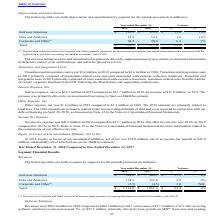According to Black Knight Financial Services's financial document, Why did Depreciation and Amortization increase? implementation of new clients, accelerated amortization of deferred contract costs and hardware and software placed in service.. The document states: "preciation and Amortization is primarily driven by implementation of new clients, accelerated amortization of deferred contract costs and hardware and..." Also, Which years does the table provide information for depreciation and amortization by segment? The document shows two values: 2019 and 2018. From the document: "2019 2018 $ % 2019 2018 $ %..." Also, What was the dollar variance for Data and Analytics? According to the financial document, 1.8 (in millions). The relevant text states: "Data and Analytics 15.9 14.1 1.8 13%..." Also, can you calculate: What was the difference in the percent variance between Software Solutions and Data and Analytics? Based on the calculation: 13-10, the result is 3 (percentage). This is based on the information: "Software Solutions $ 123.9 $ 112.9 $ 11.0 10% Data and Analytics 15.9 14.1 1.8 13%..." The key data points involved are: 10, 13. Also, can you calculate: What was the average depreciation and amortization for Software Solutions between 2018 and 2019? To answer this question, I need to perform calculations using the financial data. The calculation is: (123.9+112.9)/2, which equals 118.4 (in millions). This is based on the information: "Software Solutions $ 123.9 $ 112.9 $ 11.0 10% Software Solutions $ 123.9 $ 112.9 $ 11.0 10%..." The key data points involved are: 112.9, 123.9. Also, can you calculate: What was the average total depreciation and amortization between 2018 and 2019? To answer this question, I need to perform calculations using the financial data. The calculation is: (236.2+217.0)/2, which equals 226.6 (in millions). This is based on the information: "Total $ 236.2 $ 217.0 19.2 9% Total $ 236.2 $ 217.0 19.2 9%..." The key data points involved are: 217.0, 236.2. 